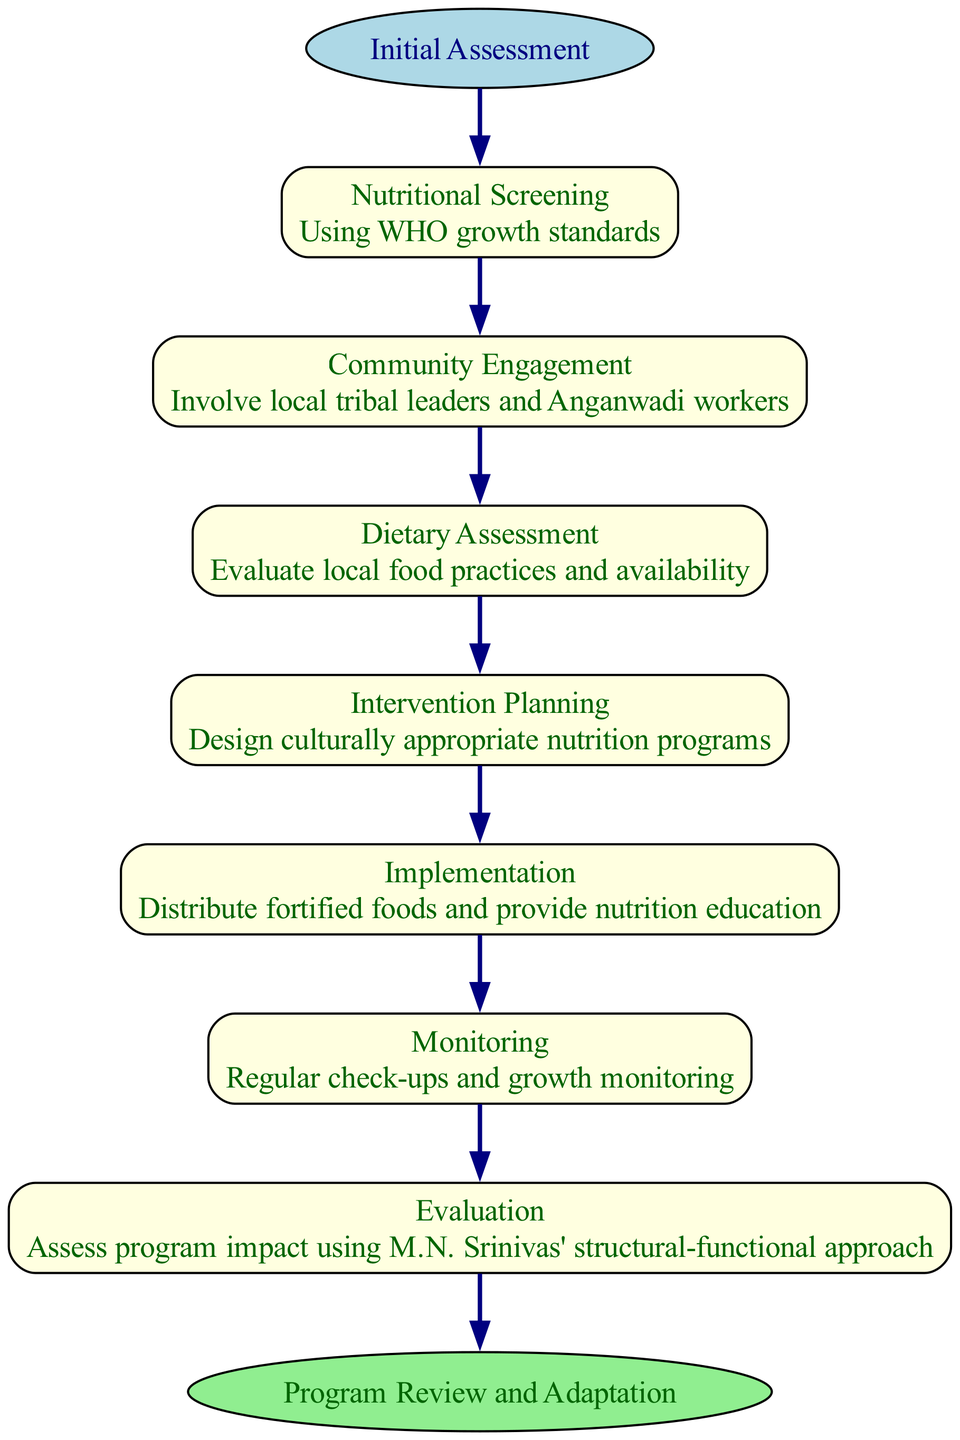What is the first step in the clinical pathway? The diagram indicates that the first step is "Nutritional Screening". This is directly shown at the beginning of the flow, following the "Initial Assessment".
Answer: Nutritional Screening How many steps are in the clinical pathway? By counting each of the step nodes listed in the diagram, there are a total of 7 steps including "Nutritional Screening" and ending with "Evaluation".
Answer: 7 What does the "Evaluation" step assess? The "Evaluation" step assesses program impact using M.N. Srinivas' structural-functional approach. This information can be found in the details provided for that specific step.
Answer: Assess program impact What is the last step in the clinical pathway? The end of the pathway is labeled "Program Review and Adaptation", which follows after all the steps have been completed. This is indicated clearly as the final node in the diagram.
Answer: Program Review and Adaptation Which step involves engaging local tribal leaders? The step that involves local tribal leaders is "Community Engagement", as stated in the details of that specific step. This node shows the connection between the community and the health outreach program.
Answer: Community Engagement What is the relationship between "Intervention Planning" and "Implementation"? "Intervention Planning" leads to "Implementation". This relationship can be seen by observing the directional edge connecting these two steps, indicating that planning occurs before implementation.
Answer: Intervention Planning leads to Implementation Which two steps occur after "Dietary Assessment"? Following the "Dietary Assessment" step, the next two steps in the pathway are "Intervention Planning" and "Implementation". The flow can be traced directly from the node of "Dietary Assessment" leading to both subsequent nodes.
Answer: Intervention Planning, Implementation What is the purpose of "Monitoring"? The purpose of the "Monitoring" step is to conduct regular check-ups and growth monitoring, as outlined in the details for this step. This is a crucial part of ensuring the effectiveness of the nutrition program.
Answer: Regular check-ups and growth monitoring 